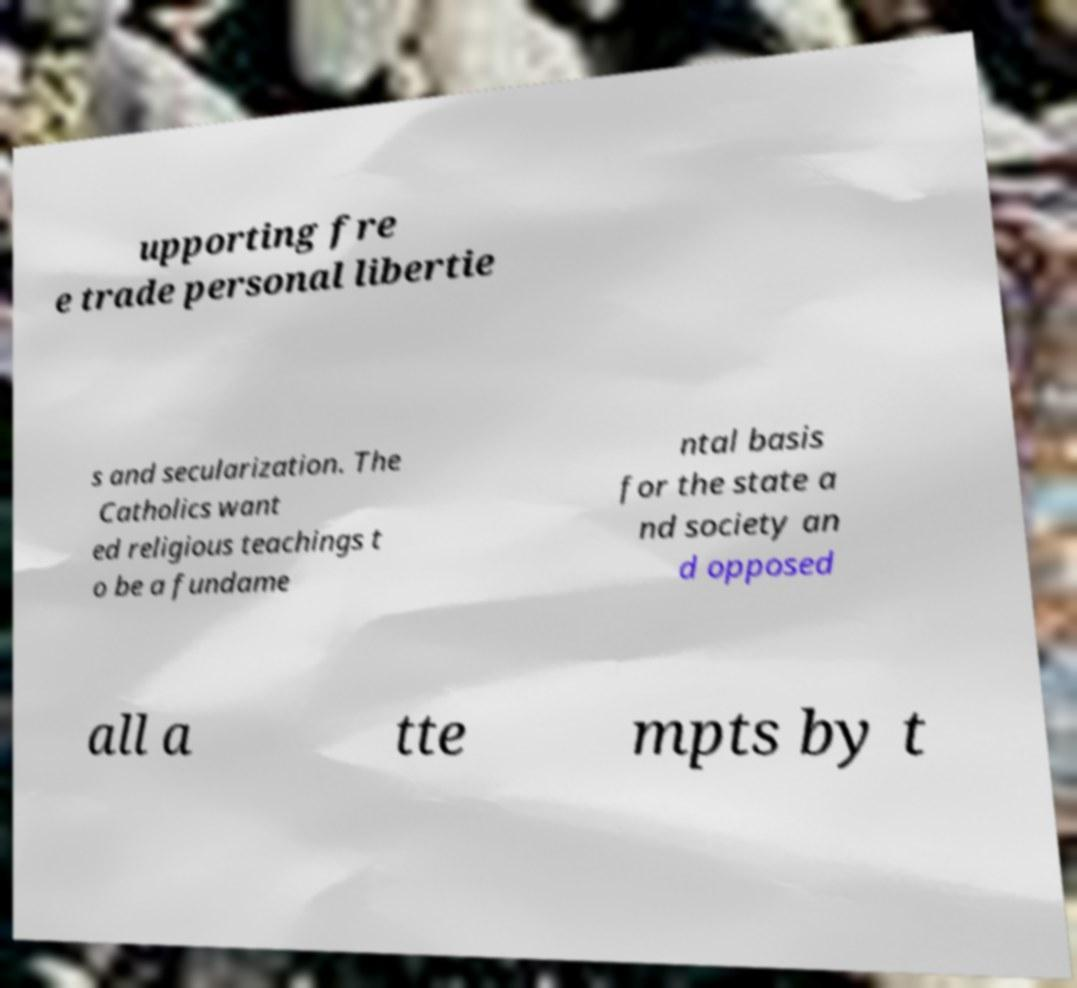There's text embedded in this image that I need extracted. Can you transcribe it verbatim? upporting fre e trade personal libertie s and secularization. The Catholics want ed religious teachings t o be a fundame ntal basis for the state a nd society an d opposed all a tte mpts by t 